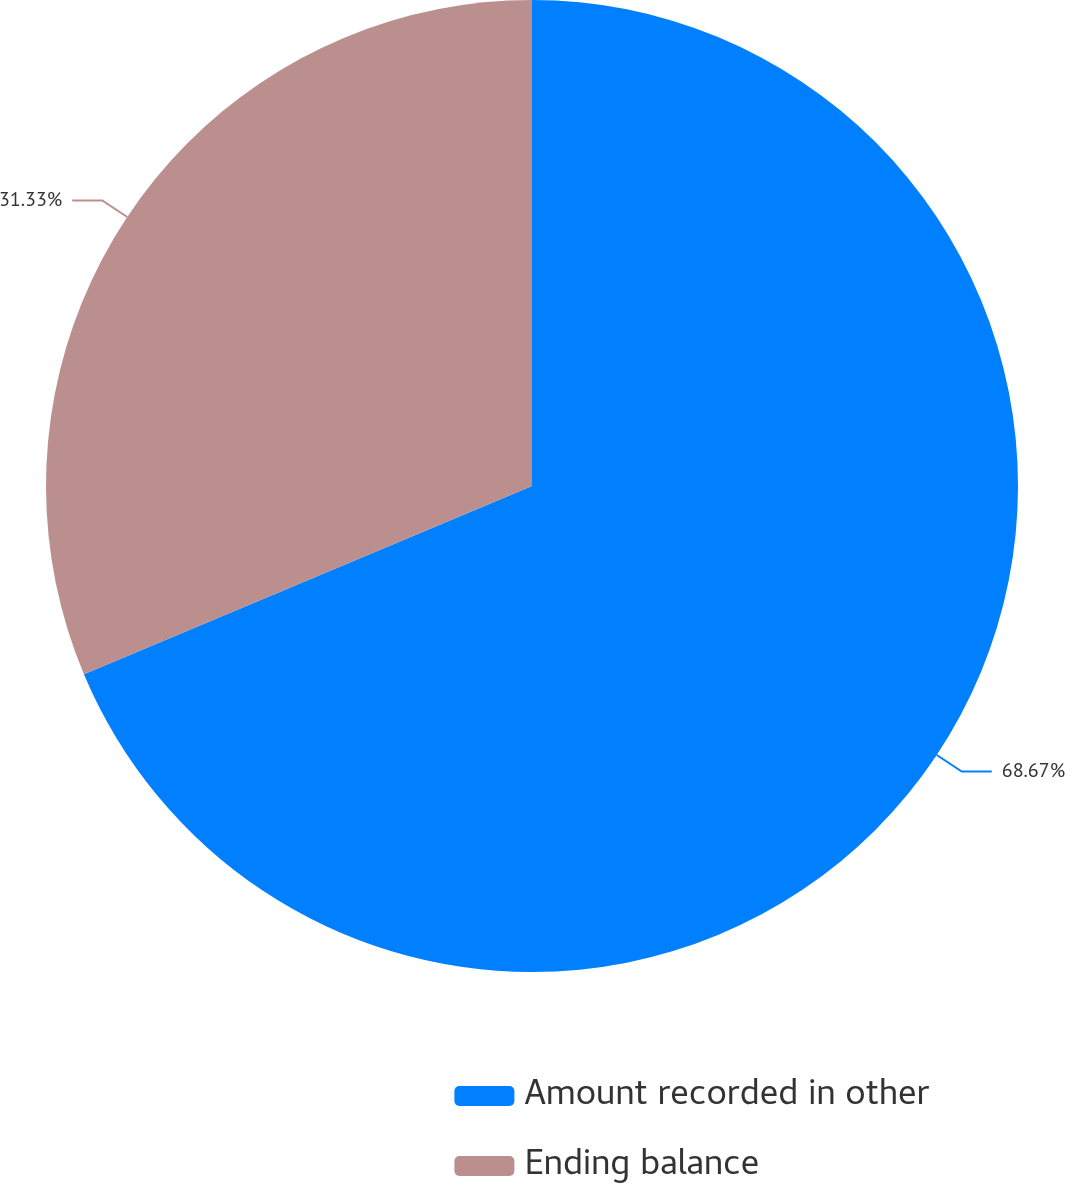<chart> <loc_0><loc_0><loc_500><loc_500><pie_chart><fcel>Amount recorded in other<fcel>Ending balance<nl><fcel>68.67%<fcel>31.33%<nl></chart> 